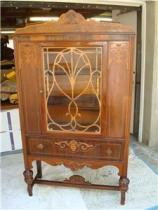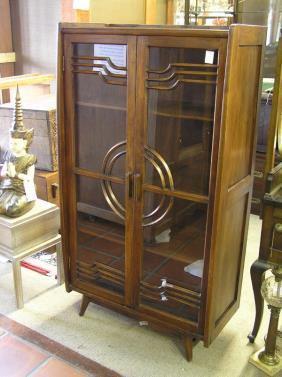The first image is the image on the left, the second image is the image on the right. For the images shown, is this caption "One wooden cabinet on tall legs has a center rectangular glass panel on the front." true? Answer yes or no. Yes. The first image is the image on the left, the second image is the image on the right. For the images displayed, is the sentence "Right image features a cabinet with slender feet instead of wedge feet." factually correct? Answer yes or no. Yes. 